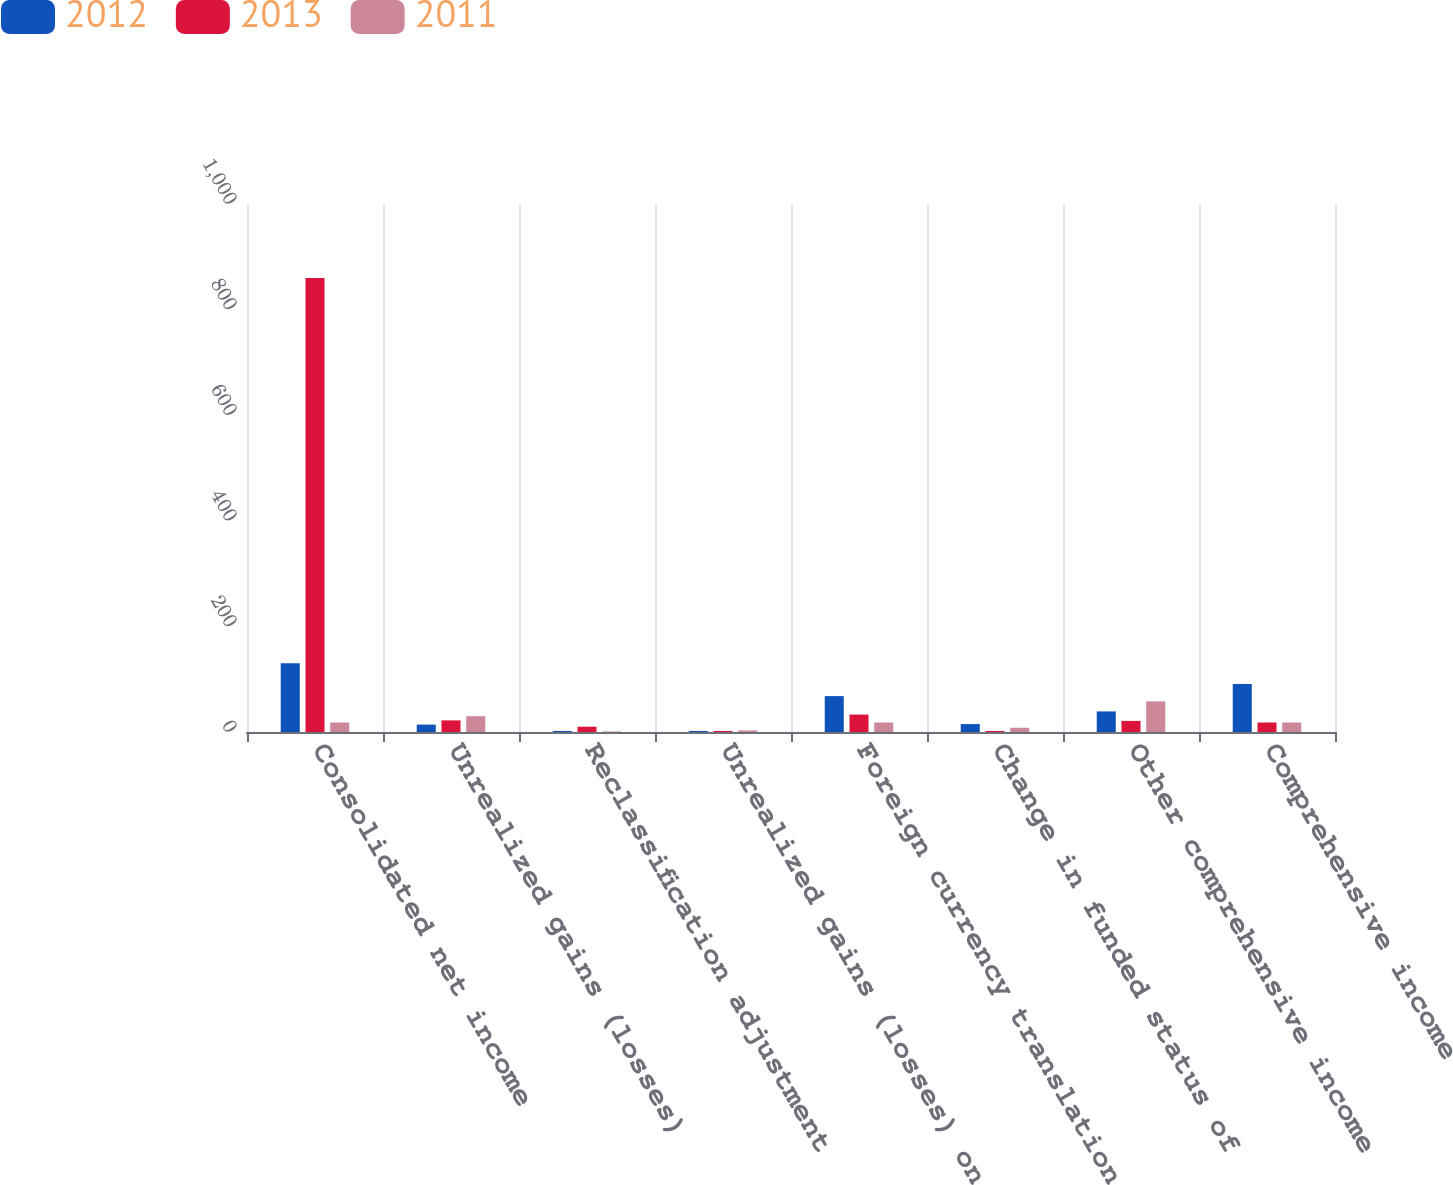Convert chart to OTSL. <chart><loc_0><loc_0><loc_500><loc_500><stacked_bar_chart><ecel><fcel>Consolidated net income<fcel>Unrealized gains (losses)<fcel>Reclassification adjustment<fcel>Unrealized gains (losses) on<fcel>Foreign currency translation<fcel>Change in funded status of<fcel>Other comprehensive income<fcel>Comprehensive income<nl><fcel>2012<fcel>130<fcel>14<fcel>2<fcel>2<fcel>68<fcel>15<fcel>39<fcel>91<nl><fcel>2013<fcel>860<fcel>22<fcel>10<fcel>2<fcel>33<fcel>2<fcel>21<fcel>18<nl><fcel>2011<fcel>18<fcel>30<fcel>1<fcel>3<fcel>18<fcel>8<fcel>58<fcel>18<nl></chart> 